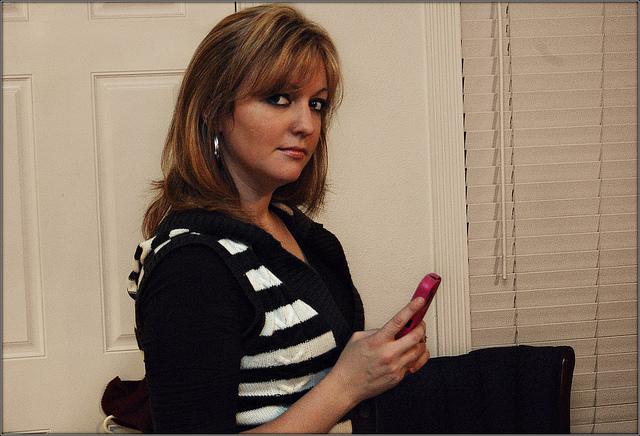What color is her shirt?
Quick response, please. Black and white. What is this girl holding?
Short answer required. Phone. What is this person holding?
Write a very short answer. Phone. Does she seem pleased with the intrusion of the photographer?
Answer briefly. No. 